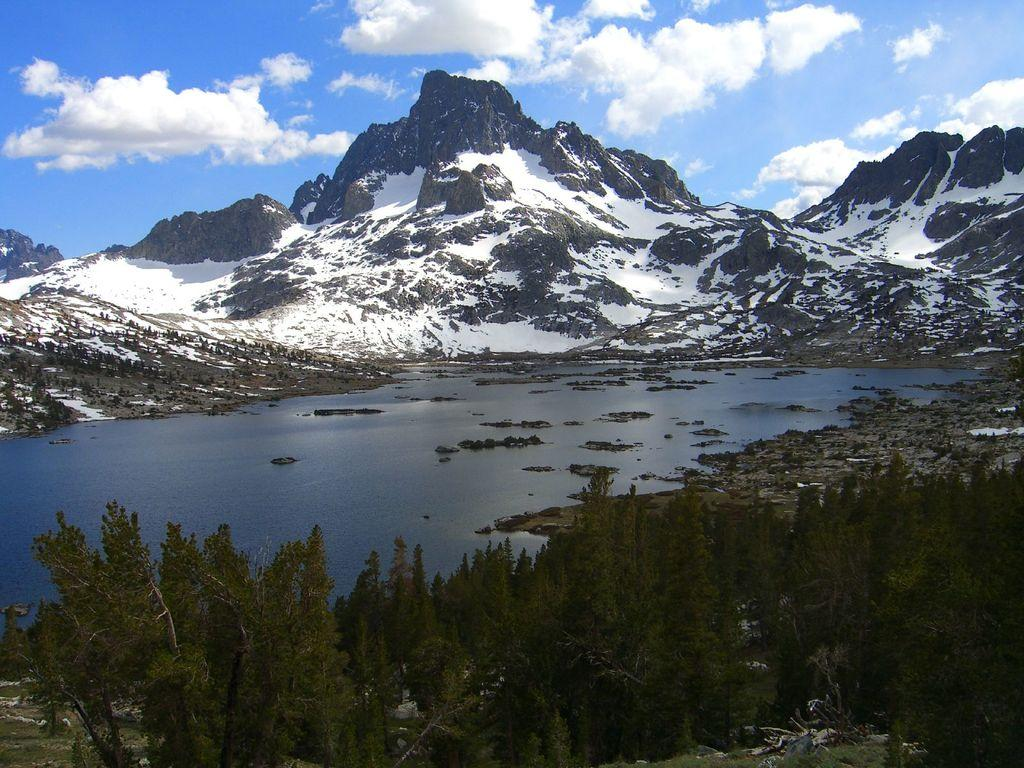What is the main subject in the center of the image? There is water in the center of the image. What type of vegetation can be seen at the bottom of the image? Trees are visible at the bottom of the image. What geographical features are present in the background of the image? There are hills in the background of the image. What part of the natural environment is visible in the background of the image? The sky is visible in the background of the image. What scientific theory can be observed in the image? There is no scientific theory present in the image; it features water, trees, hills, and the sky. 